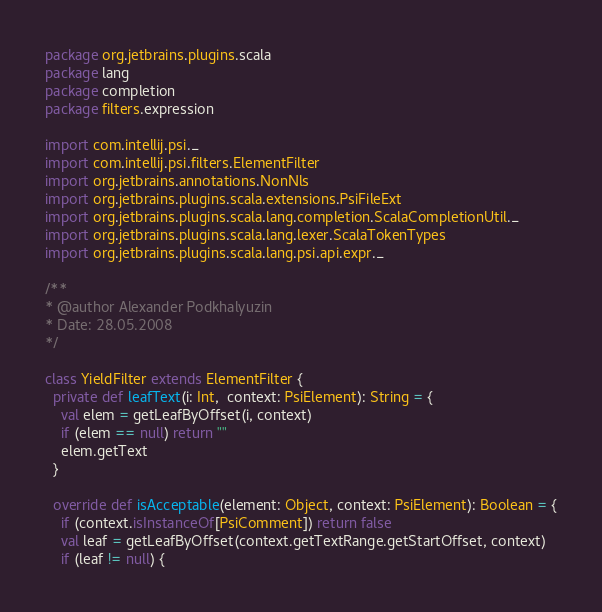<code> <loc_0><loc_0><loc_500><loc_500><_Scala_>package org.jetbrains.plugins.scala
package lang
package completion
package filters.expression

import com.intellij.psi._
import com.intellij.psi.filters.ElementFilter
import org.jetbrains.annotations.NonNls
import org.jetbrains.plugins.scala.extensions.PsiFileExt
import org.jetbrains.plugins.scala.lang.completion.ScalaCompletionUtil._
import org.jetbrains.plugins.scala.lang.lexer.ScalaTokenTypes
import org.jetbrains.plugins.scala.lang.psi.api.expr._

/**
* @author Alexander Podkhalyuzin
* Date: 28.05.2008
*/

class YieldFilter extends ElementFilter {
  private def leafText(i: Int,  context: PsiElement): String = {
    val elem = getLeafByOffset(i, context)
    if (elem == null) return ""
    elem.getText
  }

  override def isAcceptable(element: Object, context: PsiElement): Boolean = {
    if (context.isInstanceOf[PsiComment]) return false
    val leaf = getLeafByOffset(context.getTextRange.getStartOffset, context)
    if (leaf != null) {</code> 